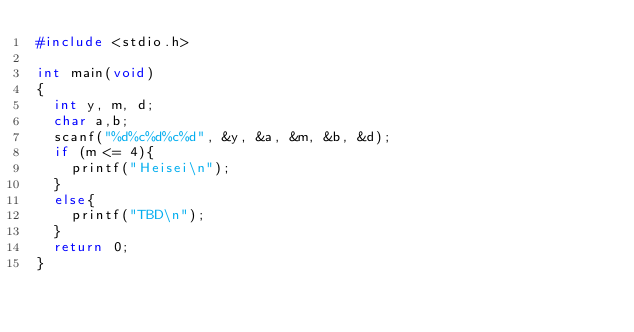Convert code to text. <code><loc_0><loc_0><loc_500><loc_500><_C_>#include <stdio.h>

int main(void)
{
  int y, m, d;
  char a,b;
  scanf("%d%c%d%c%d", &y, &a, &m, &b, &d);
  if (m <= 4){
    printf("Heisei\n");
  }
  else{
    printf("TBD\n");
  }
  return 0;
}
</code> 